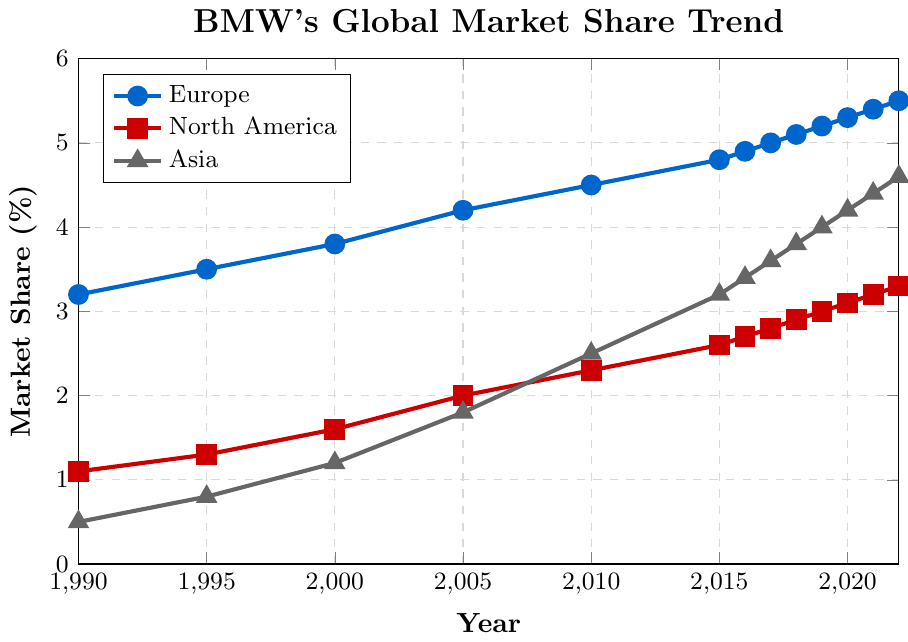Which region had the highest market share for BMW in 1990? Look at the market share values for all three regions in 1990 and compare them. Europe had 3.2%, North America 1.1%, and Asia 0.5%. Europe has the highest market share.
Answer: Europe How much did BMW's market share in North America increase from 1990 to 2022? Subtract the market share value of North America in 1990 from the value in 2022. The values are 3.3% in 2022 and 1.1% in 1990. The increase is 3.3 - 1.1 = 2.2%.
Answer: 2.2% Between which consecutive years did Europe see the greatest increase in BMW's market share? Calculate the differences in market share for Europe between each pair of consecutive years and find the maximum increase. From 1990 to 1995: 3.5 - 3.2 = 0.3, from 1995 to 2000: 3.8 - 3.5 = 0.3, etc. The greatest increase is between 2014 and 2015: 4.8 - 4.5 = 0.3.
Answer: 1990 to 1995 or 1995 to 2000 (tie) In which year did Asia's market share reach parity with North America? Identify the year where the market share values for Asia and North America are the same. This doesn't occur, but Asia continues to close in over time.
Answer: No year (Asia closes the gap gradually) What is the average market share of Europe from 1990 to 2022? Add all market share values for Europe from 1990 to 2022 and divide by the number of data points. (3.2 + 3.5 + 3.8 + 4.2 + 4.5 + 4.8 + 4.9 + 5.0 + 5.1 + 5.2 + 5.3 + 5.4 + 5.5)/13 = 4.47%
Answer: 4.47% By how much has BMW's market share in Asia increased on average every five years from 1990 to 2020? Calculate the overall increase from 1990 to 2020 for Asia and divide by the number of five-year periods. Overall increase is 4.2 - 0.5 = 3.7%. Number of five-year periods is (2020 - 1990) / 5 = 6. Average increase is 3.7 / 6 = 0.62%.
Answer: 0.62% Which region shows the most consistent growth in BMW's market share over the entire period? Assess overall trends in the line patterns; Europe and Asia show consistent upward trends but Asia has stronger increases compared to North America.
Answer: Europe What was the difference in market share between Europe and Asia in 2022? Subtract Asia's market share from Europe's market share in 2022. The values are 5.5% for Europe and 4.6% for Asia. The difference is 5.5 - 4.6 = 0.9%.
Answer: 0.9% By how much did BMW's market share in North America lag behind Europe's in 2022? Subtract North America's market share from Europe's market share in 2022. The values are 5.5% for Europe and 3.3% for North America. The lag is 5.5 - 3.3 = 2.2%.
Answer: 2.2% In which year did Asia surpass 2% market share? Locate the year where Asia's market share value first exceeds 2%. It occurs between 2005 and 2010. The value in 2010 is 2.5%, so 2010 is the year.
Answer: 2010 